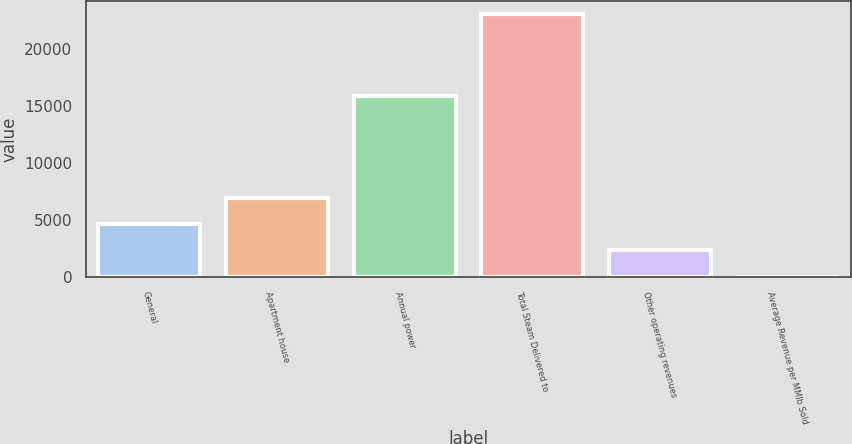Convert chart to OTSL. <chart><loc_0><loc_0><loc_500><loc_500><bar_chart><fcel>General<fcel>Apartment house<fcel>Annual power<fcel>Total Steam Delivered to<fcel>Other operating revenues<fcel>Average Revenue per MMlb Sold<nl><fcel>4626.8<fcel>6925.45<fcel>15848<fcel>23016<fcel>2328.15<fcel>29.5<nl></chart> 